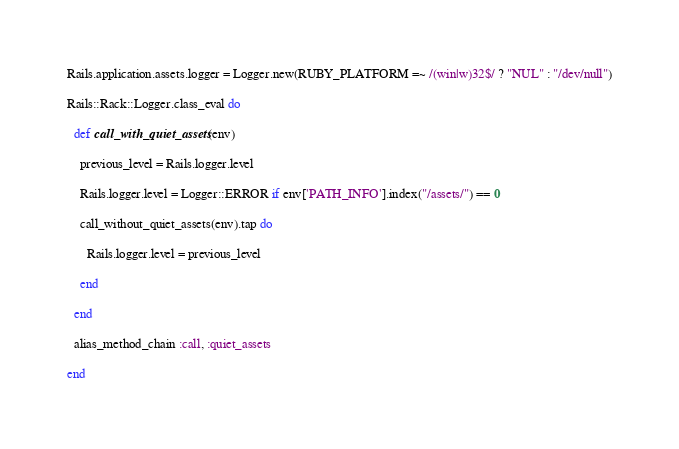<code> <loc_0><loc_0><loc_500><loc_500><_Ruby_>Rails.application.assets.logger = Logger.new(RUBY_PLATFORM =~ /(win|w)32$/ ? "NUL" : "/dev/null")
Rails::Rack::Logger.class_eval do
  def call_with_quiet_assets(env)
    previous_level = Rails.logger.level
    Rails.logger.level = Logger::ERROR if env['PATH_INFO'].index("/assets/") == 0
    call_without_quiet_assets(env).tap do
      Rails.logger.level = previous_level
    end
  end
  alias_method_chain :call, :quiet_assets
end

</code> 